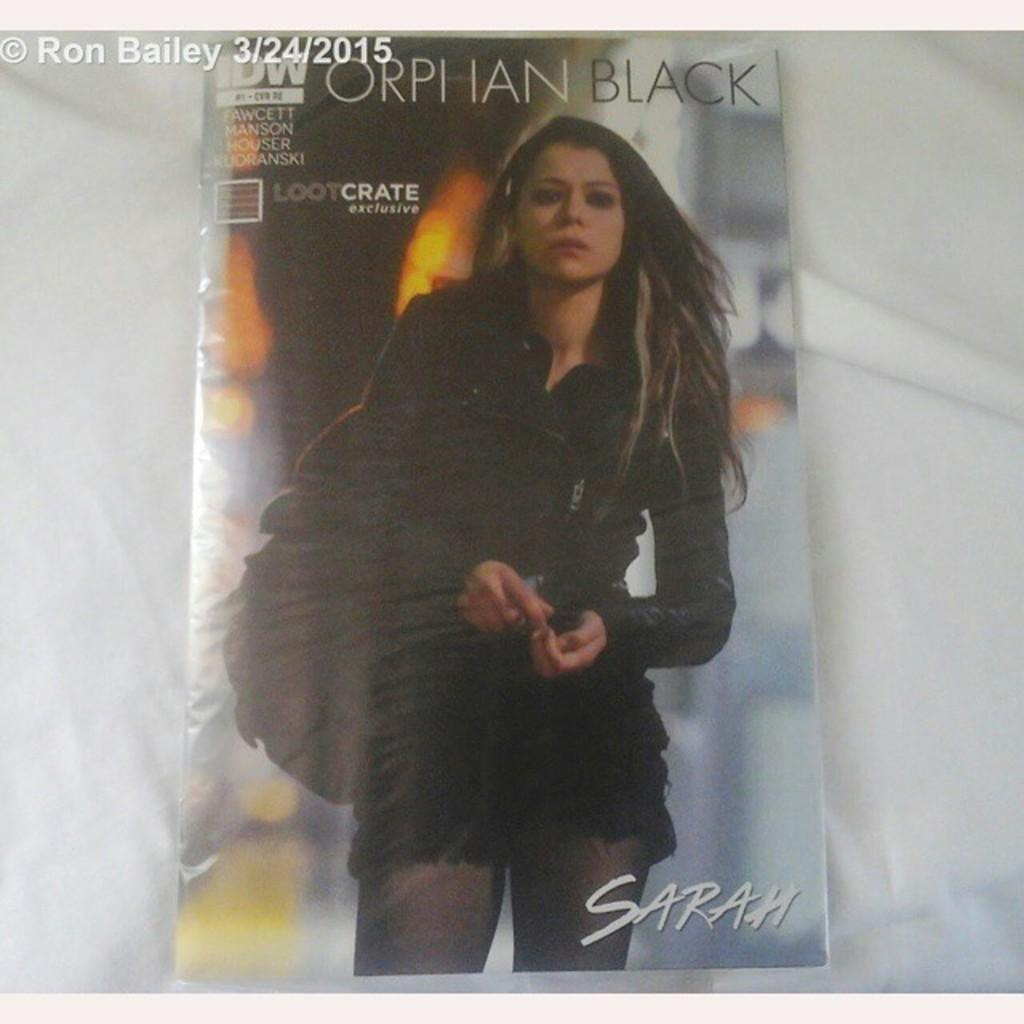What is the main object in the image? There is a magazine in the image. How is the magazine positioned in the image? The magazine is placed on a cloth. What can be seen on the cover of the magazine? The cover of the magazine features a lady. What is the lady on the cover wearing? The lady on the cover is wearing a black dress. What type of substance can be heard coming from the magazine in the image? There is no substance that can be heard coming from the magazine in the image, as it is a still image and not a video or audio recording. 